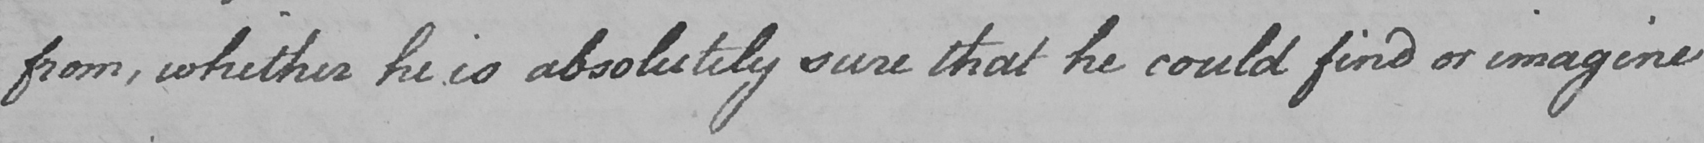Can you tell me what this handwritten text says? from , whither he is absolutely sure that he could find or imagine 